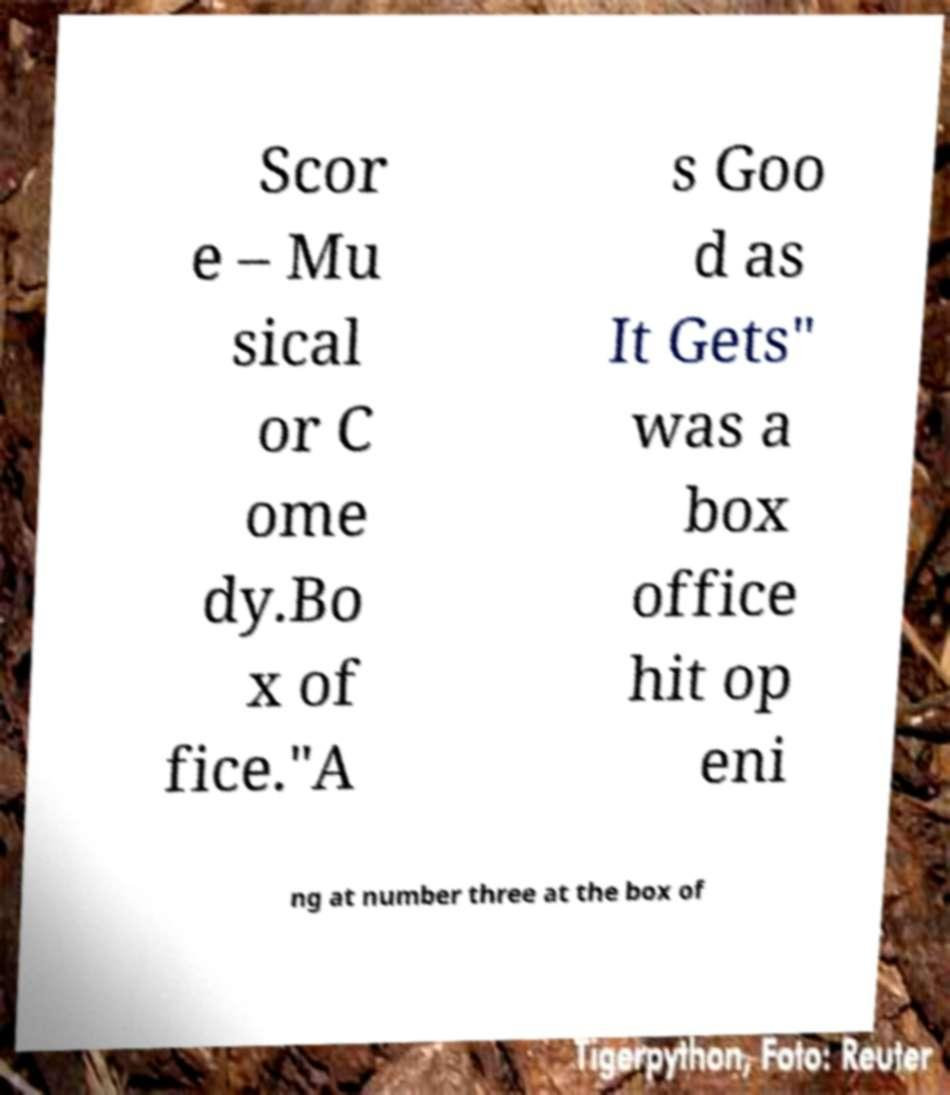There's text embedded in this image that I need extracted. Can you transcribe it verbatim? Scor e – Mu sical or C ome dy.Bo x of fice."A s Goo d as It Gets" was a box office hit op eni ng at number three at the box of 